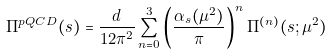<formula> <loc_0><loc_0><loc_500><loc_500>\Pi ^ { p Q C D } ( s ) = \frac { d } { 1 2 \pi ^ { 2 } } \sum _ { n = 0 } ^ { 3 } \left ( \frac { \alpha _ { s } ( \mu ^ { 2 } ) } { \pi } \right ) ^ { n } \Pi ^ { ( n ) } ( s ; \mu ^ { 2 } )</formula> 